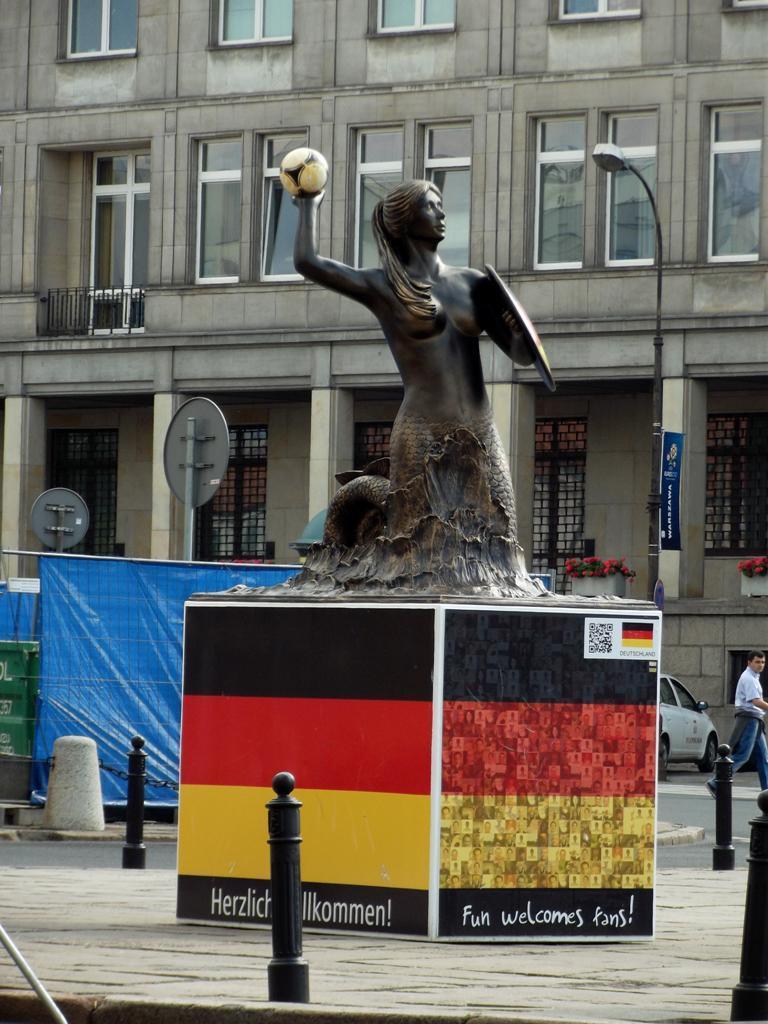Describe this image in one or two sentences. This picture is clicked outside. In the center we can see the sculpture of a mermaid on an object and we can see the text on the object and we can see the metal rods and some other objects. In the background we can see the building, net, curtains, vehicle and a person walking on the ground and we can see the potted plants and some other objects. 